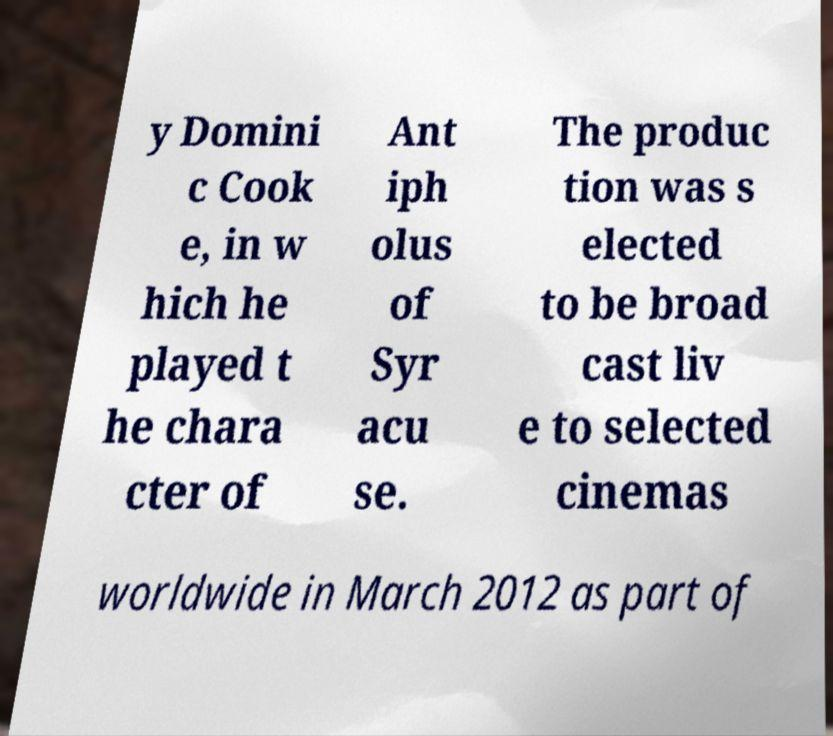Could you assist in decoding the text presented in this image and type it out clearly? y Domini c Cook e, in w hich he played t he chara cter of Ant iph olus of Syr acu se. The produc tion was s elected to be broad cast liv e to selected cinemas worldwide in March 2012 as part of 